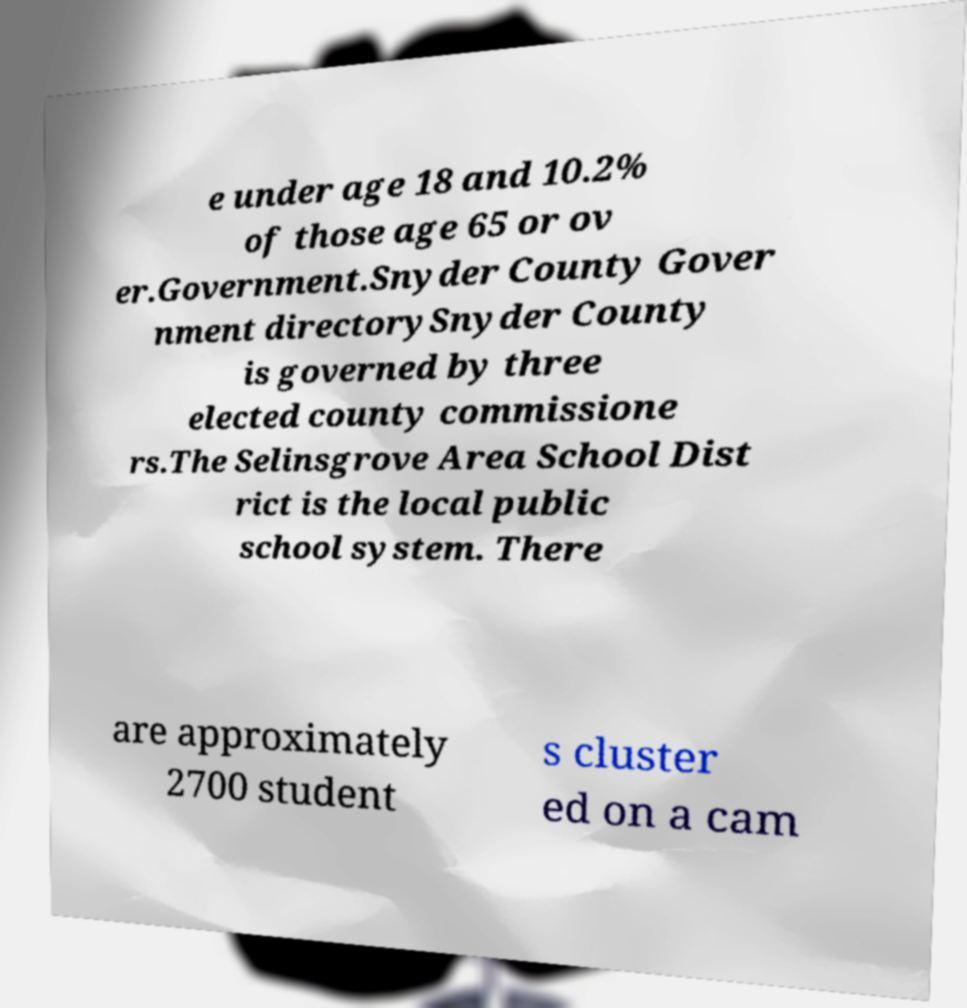Please read and relay the text visible in this image. What does it say? e under age 18 and 10.2% of those age 65 or ov er.Government.Snyder County Gover nment directorySnyder County is governed by three elected county commissione rs.The Selinsgrove Area School Dist rict is the local public school system. There are approximately 2700 student s cluster ed on a cam 